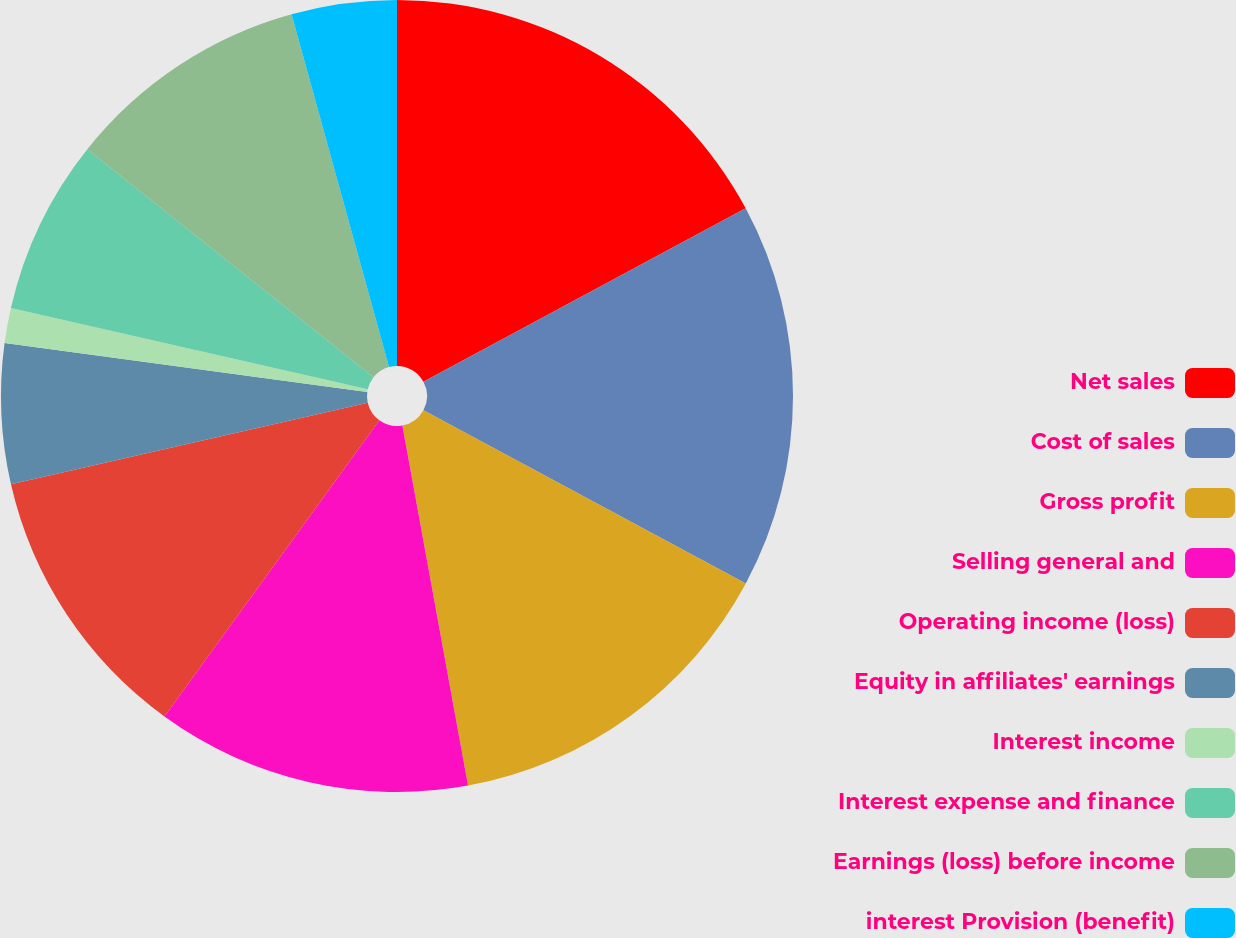Convert chart to OTSL. <chart><loc_0><loc_0><loc_500><loc_500><pie_chart><fcel>Net sales<fcel>Cost of sales<fcel>Gross profit<fcel>Selling general and<fcel>Operating income (loss)<fcel>Equity in affiliates' earnings<fcel>Interest income<fcel>Interest expense and finance<fcel>Earnings (loss) before income<fcel>interest Provision (benefit)<nl><fcel>17.14%<fcel>15.71%<fcel>14.28%<fcel>12.86%<fcel>11.43%<fcel>5.72%<fcel>1.43%<fcel>7.14%<fcel>10.0%<fcel>4.29%<nl></chart> 